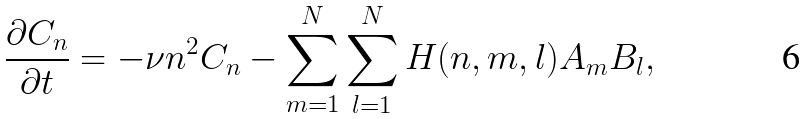<formula> <loc_0><loc_0><loc_500><loc_500>\frac { \partial C _ { n } } { \partial t } = - \nu n ^ { 2 } C _ { n } - \sum _ { m = 1 } ^ { N } \sum _ { l = 1 } ^ { N } H ( n , m , l ) A _ { m } B _ { l } ,</formula> 